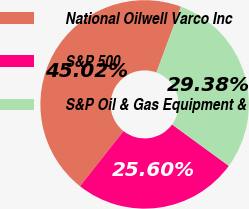Convert chart. <chart><loc_0><loc_0><loc_500><loc_500><pie_chart><fcel>National Oilwell Varco Inc<fcel>S&P 500<fcel>S&P Oil & Gas Equipment &<nl><fcel>45.02%<fcel>25.6%<fcel>29.38%<nl></chart> 